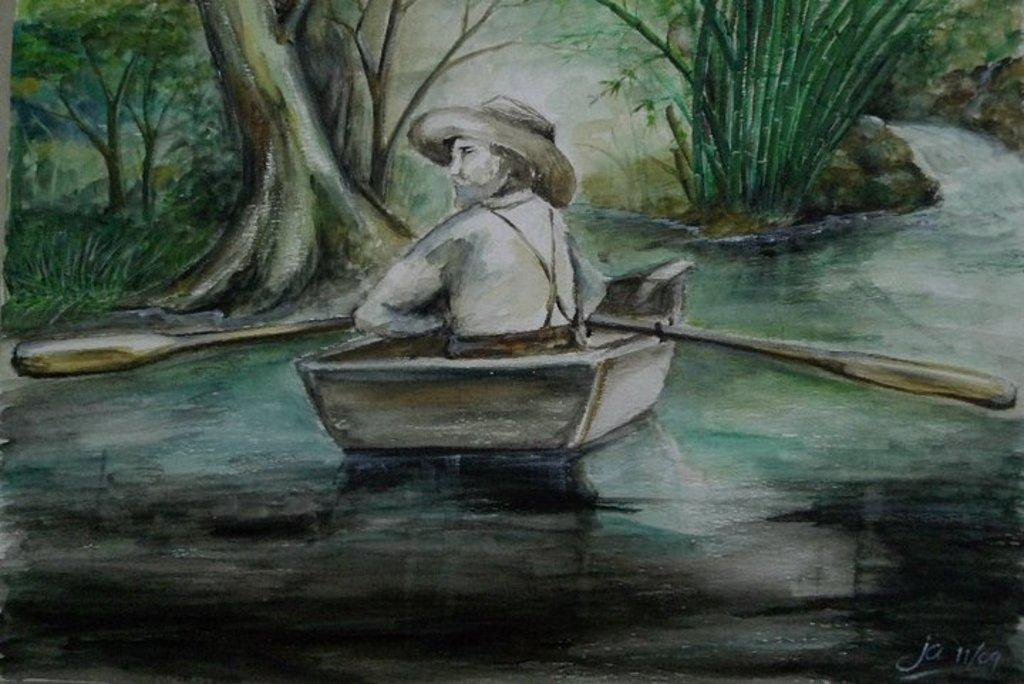What type of artwork is depicted in the image? The image is a painting. What is the person in the painting doing? The person is sitting in a boat. What is the person using to propel the boat? The person is holding paddles. Where is the boat located in the painting? The boat is on water. What can be seen in the background of the painting? There are plants and trees in the background of the painting. How many ladybugs are sitting on the person's shoulder in the painting? There are no ladybugs present in the painting. What is the relationship between the person and the women in the painting? There are no women depicted in the painting; only a person sitting in a boat is visible. 